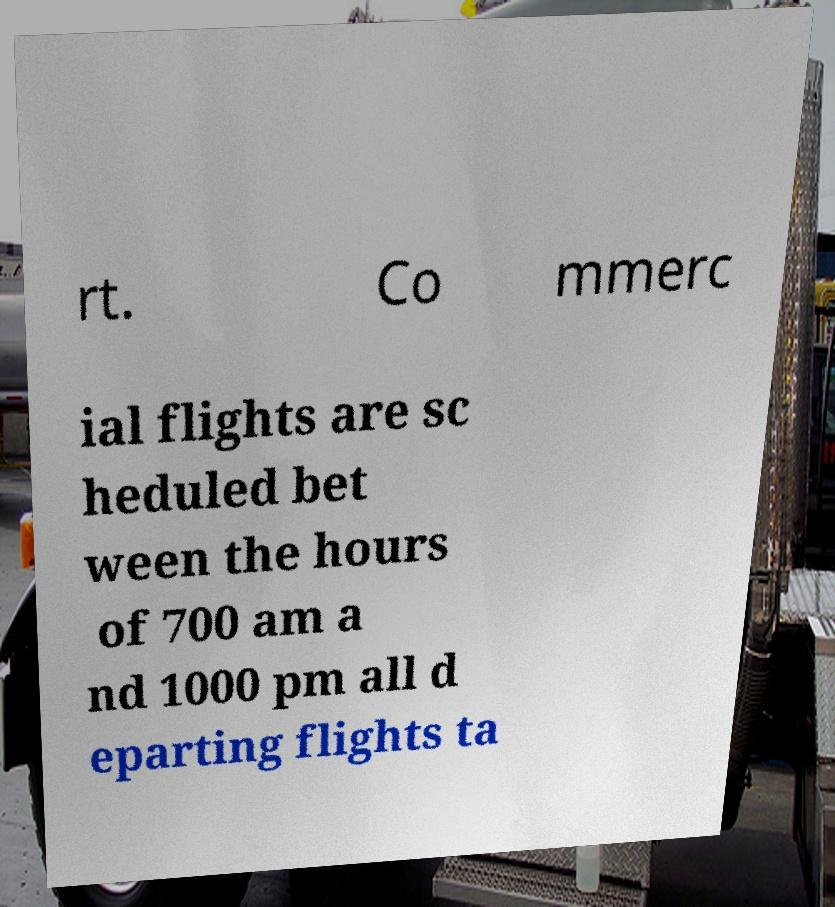Please read and relay the text visible in this image. What does it say? rt. Co mmerc ial flights are sc heduled bet ween the hours of 700 am a nd 1000 pm all d eparting flights ta 